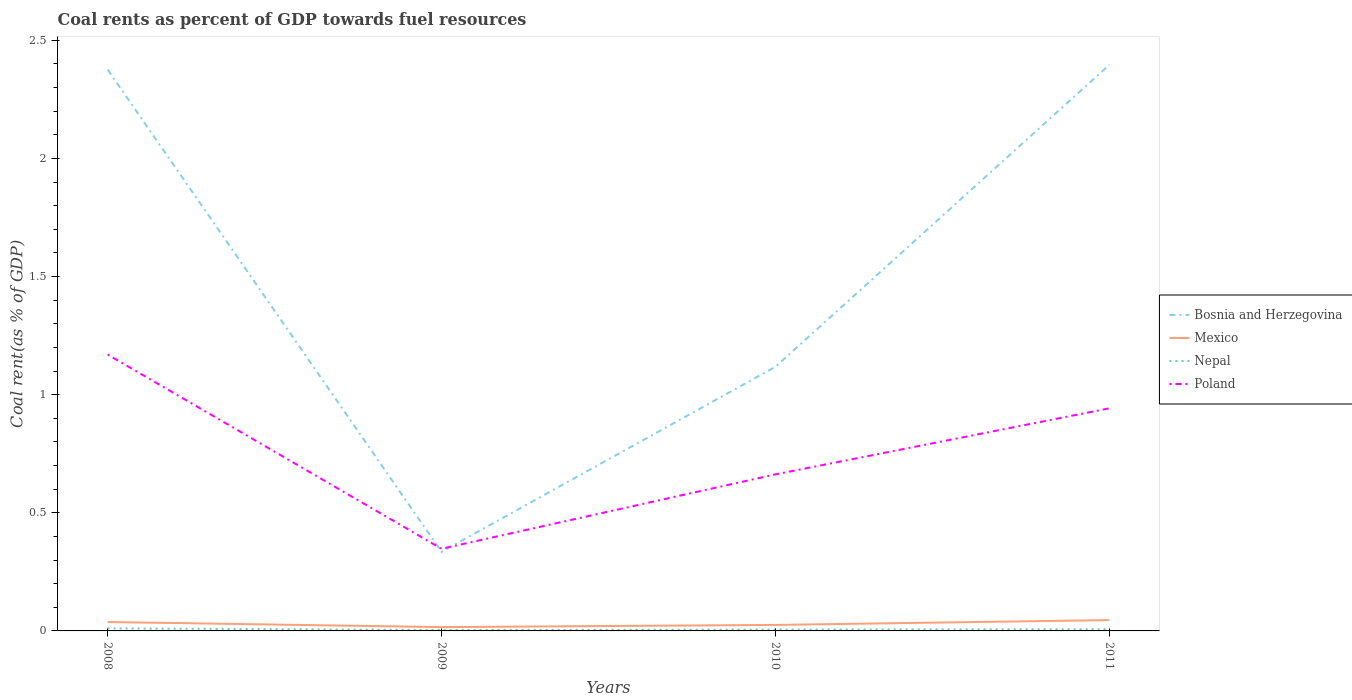How many different coloured lines are there?
Offer a terse response. 4. Is the number of lines equal to the number of legend labels?
Your answer should be very brief. Yes. Across all years, what is the maximum coal rent in Mexico?
Provide a succinct answer. 0.02. What is the total coal rent in Bosnia and Herzegovina in the graph?
Your answer should be compact. 2.04. What is the difference between the highest and the second highest coal rent in Nepal?
Make the answer very short. 0.01. How many years are there in the graph?
Provide a short and direct response. 4. Are the values on the major ticks of Y-axis written in scientific E-notation?
Offer a very short reply. No. Does the graph contain grids?
Keep it short and to the point. No. Where does the legend appear in the graph?
Keep it short and to the point. Center right. How are the legend labels stacked?
Provide a succinct answer. Vertical. What is the title of the graph?
Your answer should be compact. Coal rents as percent of GDP towards fuel resources. What is the label or title of the X-axis?
Your answer should be very brief. Years. What is the label or title of the Y-axis?
Give a very brief answer. Coal rent(as % of GDP). What is the Coal rent(as % of GDP) in Bosnia and Herzegovina in 2008?
Ensure brevity in your answer.  2.38. What is the Coal rent(as % of GDP) in Mexico in 2008?
Make the answer very short. 0.04. What is the Coal rent(as % of GDP) of Nepal in 2008?
Your answer should be compact. 0.01. What is the Coal rent(as % of GDP) of Poland in 2008?
Provide a succinct answer. 1.17. What is the Coal rent(as % of GDP) of Bosnia and Herzegovina in 2009?
Make the answer very short. 0.33. What is the Coal rent(as % of GDP) of Mexico in 2009?
Offer a very short reply. 0.02. What is the Coal rent(as % of GDP) of Nepal in 2009?
Give a very brief answer. 0. What is the Coal rent(as % of GDP) in Poland in 2009?
Your response must be concise. 0.35. What is the Coal rent(as % of GDP) of Bosnia and Herzegovina in 2010?
Offer a terse response. 1.12. What is the Coal rent(as % of GDP) of Mexico in 2010?
Make the answer very short. 0.03. What is the Coal rent(as % of GDP) of Nepal in 2010?
Your answer should be compact. 0.01. What is the Coal rent(as % of GDP) of Poland in 2010?
Make the answer very short. 0.66. What is the Coal rent(as % of GDP) in Bosnia and Herzegovina in 2011?
Keep it short and to the point. 2.4. What is the Coal rent(as % of GDP) of Mexico in 2011?
Offer a very short reply. 0.05. What is the Coal rent(as % of GDP) in Nepal in 2011?
Keep it short and to the point. 0.01. What is the Coal rent(as % of GDP) in Poland in 2011?
Your answer should be very brief. 0.94. Across all years, what is the maximum Coal rent(as % of GDP) in Bosnia and Herzegovina?
Make the answer very short. 2.4. Across all years, what is the maximum Coal rent(as % of GDP) of Mexico?
Your answer should be compact. 0.05. Across all years, what is the maximum Coal rent(as % of GDP) of Nepal?
Ensure brevity in your answer.  0.01. Across all years, what is the maximum Coal rent(as % of GDP) of Poland?
Offer a very short reply. 1.17. Across all years, what is the minimum Coal rent(as % of GDP) in Bosnia and Herzegovina?
Provide a short and direct response. 0.33. Across all years, what is the minimum Coal rent(as % of GDP) of Mexico?
Your answer should be very brief. 0.02. Across all years, what is the minimum Coal rent(as % of GDP) in Nepal?
Ensure brevity in your answer.  0. Across all years, what is the minimum Coal rent(as % of GDP) in Poland?
Offer a very short reply. 0.35. What is the total Coal rent(as % of GDP) of Bosnia and Herzegovina in the graph?
Your answer should be very brief. 6.23. What is the total Coal rent(as % of GDP) in Mexico in the graph?
Your answer should be compact. 0.13. What is the total Coal rent(as % of GDP) of Nepal in the graph?
Offer a very short reply. 0.03. What is the total Coal rent(as % of GDP) of Poland in the graph?
Your answer should be very brief. 3.12. What is the difference between the Coal rent(as % of GDP) of Bosnia and Herzegovina in 2008 and that in 2009?
Offer a terse response. 2.04. What is the difference between the Coal rent(as % of GDP) in Mexico in 2008 and that in 2009?
Provide a succinct answer. 0.02. What is the difference between the Coal rent(as % of GDP) of Nepal in 2008 and that in 2009?
Your response must be concise. 0.01. What is the difference between the Coal rent(as % of GDP) of Poland in 2008 and that in 2009?
Provide a short and direct response. 0.82. What is the difference between the Coal rent(as % of GDP) of Bosnia and Herzegovina in 2008 and that in 2010?
Make the answer very short. 1.26. What is the difference between the Coal rent(as % of GDP) of Mexico in 2008 and that in 2010?
Your answer should be very brief. 0.01. What is the difference between the Coal rent(as % of GDP) of Nepal in 2008 and that in 2010?
Offer a very short reply. 0. What is the difference between the Coal rent(as % of GDP) of Poland in 2008 and that in 2010?
Provide a short and direct response. 0.51. What is the difference between the Coal rent(as % of GDP) in Bosnia and Herzegovina in 2008 and that in 2011?
Keep it short and to the point. -0.02. What is the difference between the Coal rent(as % of GDP) of Mexico in 2008 and that in 2011?
Ensure brevity in your answer.  -0.01. What is the difference between the Coal rent(as % of GDP) of Nepal in 2008 and that in 2011?
Offer a terse response. 0. What is the difference between the Coal rent(as % of GDP) in Poland in 2008 and that in 2011?
Provide a short and direct response. 0.23. What is the difference between the Coal rent(as % of GDP) of Bosnia and Herzegovina in 2009 and that in 2010?
Your answer should be compact. -0.78. What is the difference between the Coal rent(as % of GDP) of Mexico in 2009 and that in 2010?
Offer a terse response. -0.01. What is the difference between the Coal rent(as % of GDP) of Nepal in 2009 and that in 2010?
Your answer should be compact. -0. What is the difference between the Coal rent(as % of GDP) in Poland in 2009 and that in 2010?
Provide a succinct answer. -0.32. What is the difference between the Coal rent(as % of GDP) in Bosnia and Herzegovina in 2009 and that in 2011?
Provide a succinct answer. -2.06. What is the difference between the Coal rent(as % of GDP) in Mexico in 2009 and that in 2011?
Your response must be concise. -0.03. What is the difference between the Coal rent(as % of GDP) of Nepal in 2009 and that in 2011?
Your answer should be very brief. -0. What is the difference between the Coal rent(as % of GDP) of Poland in 2009 and that in 2011?
Make the answer very short. -0.59. What is the difference between the Coal rent(as % of GDP) of Bosnia and Herzegovina in 2010 and that in 2011?
Provide a short and direct response. -1.28. What is the difference between the Coal rent(as % of GDP) in Mexico in 2010 and that in 2011?
Provide a succinct answer. -0.02. What is the difference between the Coal rent(as % of GDP) of Nepal in 2010 and that in 2011?
Your response must be concise. -0. What is the difference between the Coal rent(as % of GDP) in Poland in 2010 and that in 2011?
Provide a short and direct response. -0.28. What is the difference between the Coal rent(as % of GDP) of Bosnia and Herzegovina in 2008 and the Coal rent(as % of GDP) of Mexico in 2009?
Give a very brief answer. 2.36. What is the difference between the Coal rent(as % of GDP) in Bosnia and Herzegovina in 2008 and the Coal rent(as % of GDP) in Nepal in 2009?
Offer a terse response. 2.37. What is the difference between the Coal rent(as % of GDP) of Bosnia and Herzegovina in 2008 and the Coal rent(as % of GDP) of Poland in 2009?
Your answer should be very brief. 2.03. What is the difference between the Coal rent(as % of GDP) in Mexico in 2008 and the Coal rent(as % of GDP) in Nepal in 2009?
Your response must be concise. 0.03. What is the difference between the Coal rent(as % of GDP) of Mexico in 2008 and the Coal rent(as % of GDP) of Poland in 2009?
Your answer should be very brief. -0.31. What is the difference between the Coal rent(as % of GDP) in Nepal in 2008 and the Coal rent(as % of GDP) in Poland in 2009?
Keep it short and to the point. -0.34. What is the difference between the Coal rent(as % of GDP) in Bosnia and Herzegovina in 2008 and the Coal rent(as % of GDP) in Mexico in 2010?
Make the answer very short. 2.35. What is the difference between the Coal rent(as % of GDP) in Bosnia and Herzegovina in 2008 and the Coal rent(as % of GDP) in Nepal in 2010?
Provide a short and direct response. 2.37. What is the difference between the Coal rent(as % of GDP) of Bosnia and Herzegovina in 2008 and the Coal rent(as % of GDP) of Poland in 2010?
Offer a terse response. 1.71. What is the difference between the Coal rent(as % of GDP) in Mexico in 2008 and the Coal rent(as % of GDP) in Nepal in 2010?
Your answer should be very brief. 0.03. What is the difference between the Coal rent(as % of GDP) in Mexico in 2008 and the Coal rent(as % of GDP) in Poland in 2010?
Offer a very short reply. -0.62. What is the difference between the Coal rent(as % of GDP) in Nepal in 2008 and the Coal rent(as % of GDP) in Poland in 2010?
Make the answer very short. -0.65. What is the difference between the Coal rent(as % of GDP) in Bosnia and Herzegovina in 2008 and the Coal rent(as % of GDP) in Mexico in 2011?
Your answer should be very brief. 2.33. What is the difference between the Coal rent(as % of GDP) of Bosnia and Herzegovina in 2008 and the Coal rent(as % of GDP) of Nepal in 2011?
Ensure brevity in your answer.  2.37. What is the difference between the Coal rent(as % of GDP) of Bosnia and Herzegovina in 2008 and the Coal rent(as % of GDP) of Poland in 2011?
Offer a very short reply. 1.43. What is the difference between the Coal rent(as % of GDP) of Mexico in 2008 and the Coal rent(as % of GDP) of Nepal in 2011?
Provide a short and direct response. 0.03. What is the difference between the Coal rent(as % of GDP) in Mexico in 2008 and the Coal rent(as % of GDP) in Poland in 2011?
Give a very brief answer. -0.9. What is the difference between the Coal rent(as % of GDP) in Nepal in 2008 and the Coal rent(as % of GDP) in Poland in 2011?
Provide a succinct answer. -0.93. What is the difference between the Coal rent(as % of GDP) in Bosnia and Herzegovina in 2009 and the Coal rent(as % of GDP) in Mexico in 2010?
Ensure brevity in your answer.  0.31. What is the difference between the Coal rent(as % of GDP) in Bosnia and Herzegovina in 2009 and the Coal rent(as % of GDP) in Nepal in 2010?
Provide a short and direct response. 0.33. What is the difference between the Coal rent(as % of GDP) of Bosnia and Herzegovina in 2009 and the Coal rent(as % of GDP) of Poland in 2010?
Offer a very short reply. -0.33. What is the difference between the Coal rent(as % of GDP) of Mexico in 2009 and the Coal rent(as % of GDP) of Nepal in 2010?
Your answer should be compact. 0.01. What is the difference between the Coal rent(as % of GDP) in Mexico in 2009 and the Coal rent(as % of GDP) in Poland in 2010?
Make the answer very short. -0.65. What is the difference between the Coal rent(as % of GDP) in Nepal in 2009 and the Coal rent(as % of GDP) in Poland in 2010?
Keep it short and to the point. -0.66. What is the difference between the Coal rent(as % of GDP) of Bosnia and Herzegovina in 2009 and the Coal rent(as % of GDP) of Mexico in 2011?
Your answer should be very brief. 0.29. What is the difference between the Coal rent(as % of GDP) in Bosnia and Herzegovina in 2009 and the Coal rent(as % of GDP) in Nepal in 2011?
Ensure brevity in your answer.  0.33. What is the difference between the Coal rent(as % of GDP) in Bosnia and Herzegovina in 2009 and the Coal rent(as % of GDP) in Poland in 2011?
Make the answer very short. -0.61. What is the difference between the Coal rent(as % of GDP) of Mexico in 2009 and the Coal rent(as % of GDP) of Nepal in 2011?
Ensure brevity in your answer.  0.01. What is the difference between the Coal rent(as % of GDP) of Mexico in 2009 and the Coal rent(as % of GDP) of Poland in 2011?
Offer a very short reply. -0.93. What is the difference between the Coal rent(as % of GDP) of Nepal in 2009 and the Coal rent(as % of GDP) of Poland in 2011?
Give a very brief answer. -0.94. What is the difference between the Coal rent(as % of GDP) in Bosnia and Herzegovina in 2010 and the Coal rent(as % of GDP) in Mexico in 2011?
Your answer should be very brief. 1.07. What is the difference between the Coal rent(as % of GDP) in Bosnia and Herzegovina in 2010 and the Coal rent(as % of GDP) in Nepal in 2011?
Provide a short and direct response. 1.11. What is the difference between the Coal rent(as % of GDP) in Bosnia and Herzegovina in 2010 and the Coal rent(as % of GDP) in Poland in 2011?
Your answer should be very brief. 0.18. What is the difference between the Coal rent(as % of GDP) of Mexico in 2010 and the Coal rent(as % of GDP) of Nepal in 2011?
Provide a short and direct response. 0.02. What is the difference between the Coal rent(as % of GDP) of Mexico in 2010 and the Coal rent(as % of GDP) of Poland in 2011?
Give a very brief answer. -0.92. What is the difference between the Coal rent(as % of GDP) of Nepal in 2010 and the Coal rent(as % of GDP) of Poland in 2011?
Provide a succinct answer. -0.94. What is the average Coal rent(as % of GDP) of Bosnia and Herzegovina per year?
Your answer should be very brief. 1.56. What is the average Coal rent(as % of GDP) in Mexico per year?
Offer a very short reply. 0.03. What is the average Coal rent(as % of GDP) of Nepal per year?
Keep it short and to the point. 0.01. What is the average Coal rent(as % of GDP) of Poland per year?
Your answer should be very brief. 0.78. In the year 2008, what is the difference between the Coal rent(as % of GDP) of Bosnia and Herzegovina and Coal rent(as % of GDP) of Mexico?
Your answer should be very brief. 2.34. In the year 2008, what is the difference between the Coal rent(as % of GDP) of Bosnia and Herzegovina and Coal rent(as % of GDP) of Nepal?
Give a very brief answer. 2.37. In the year 2008, what is the difference between the Coal rent(as % of GDP) in Bosnia and Herzegovina and Coal rent(as % of GDP) in Poland?
Provide a short and direct response. 1.21. In the year 2008, what is the difference between the Coal rent(as % of GDP) in Mexico and Coal rent(as % of GDP) in Nepal?
Your answer should be compact. 0.03. In the year 2008, what is the difference between the Coal rent(as % of GDP) in Mexico and Coal rent(as % of GDP) in Poland?
Offer a very short reply. -1.13. In the year 2008, what is the difference between the Coal rent(as % of GDP) of Nepal and Coal rent(as % of GDP) of Poland?
Provide a succinct answer. -1.16. In the year 2009, what is the difference between the Coal rent(as % of GDP) of Bosnia and Herzegovina and Coal rent(as % of GDP) of Mexico?
Your answer should be very brief. 0.32. In the year 2009, what is the difference between the Coal rent(as % of GDP) of Bosnia and Herzegovina and Coal rent(as % of GDP) of Nepal?
Ensure brevity in your answer.  0.33. In the year 2009, what is the difference between the Coal rent(as % of GDP) of Bosnia and Herzegovina and Coal rent(as % of GDP) of Poland?
Offer a terse response. -0.01. In the year 2009, what is the difference between the Coal rent(as % of GDP) of Mexico and Coal rent(as % of GDP) of Nepal?
Ensure brevity in your answer.  0.01. In the year 2009, what is the difference between the Coal rent(as % of GDP) in Mexico and Coal rent(as % of GDP) in Poland?
Give a very brief answer. -0.33. In the year 2009, what is the difference between the Coal rent(as % of GDP) in Nepal and Coal rent(as % of GDP) in Poland?
Offer a very short reply. -0.34. In the year 2010, what is the difference between the Coal rent(as % of GDP) in Bosnia and Herzegovina and Coal rent(as % of GDP) in Mexico?
Keep it short and to the point. 1.09. In the year 2010, what is the difference between the Coal rent(as % of GDP) in Bosnia and Herzegovina and Coal rent(as % of GDP) in Nepal?
Your answer should be very brief. 1.11. In the year 2010, what is the difference between the Coal rent(as % of GDP) of Bosnia and Herzegovina and Coal rent(as % of GDP) of Poland?
Your answer should be compact. 0.46. In the year 2010, what is the difference between the Coal rent(as % of GDP) in Mexico and Coal rent(as % of GDP) in Nepal?
Your answer should be very brief. 0.02. In the year 2010, what is the difference between the Coal rent(as % of GDP) of Mexico and Coal rent(as % of GDP) of Poland?
Offer a terse response. -0.64. In the year 2010, what is the difference between the Coal rent(as % of GDP) in Nepal and Coal rent(as % of GDP) in Poland?
Offer a terse response. -0.66. In the year 2011, what is the difference between the Coal rent(as % of GDP) in Bosnia and Herzegovina and Coal rent(as % of GDP) in Mexico?
Offer a very short reply. 2.35. In the year 2011, what is the difference between the Coal rent(as % of GDP) in Bosnia and Herzegovina and Coal rent(as % of GDP) in Nepal?
Your response must be concise. 2.39. In the year 2011, what is the difference between the Coal rent(as % of GDP) in Bosnia and Herzegovina and Coal rent(as % of GDP) in Poland?
Offer a terse response. 1.45. In the year 2011, what is the difference between the Coal rent(as % of GDP) of Mexico and Coal rent(as % of GDP) of Nepal?
Offer a very short reply. 0.04. In the year 2011, what is the difference between the Coal rent(as % of GDP) in Mexico and Coal rent(as % of GDP) in Poland?
Ensure brevity in your answer.  -0.9. In the year 2011, what is the difference between the Coal rent(as % of GDP) of Nepal and Coal rent(as % of GDP) of Poland?
Your response must be concise. -0.94. What is the ratio of the Coal rent(as % of GDP) in Bosnia and Herzegovina in 2008 to that in 2009?
Provide a short and direct response. 7.1. What is the ratio of the Coal rent(as % of GDP) of Mexico in 2008 to that in 2009?
Offer a very short reply. 2.33. What is the ratio of the Coal rent(as % of GDP) in Nepal in 2008 to that in 2009?
Provide a succinct answer. 2.57. What is the ratio of the Coal rent(as % of GDP) of Poland in 2008 to that in 2009?
Your answer should be very brief. 3.36. What is the ratio of the Coal rent(as % of GDP) of Bosnia and Herzegovina in 2008 to that in 2010?
Provide a succinct answer. 2.13. What is the ratio of the Coal rent(as % of GDP) of Mexico in 2008 to that in 2010?
Your response must be concise. 1.48. What is the ratio of the Coal rent(as % of GDP) in Nepal in 2008 to that in 2010?
Ensure brevity in your answer.  1.85. What is the ratio of the Coal rent(as % of GDP) of Poland in 2008 to that in 2010?
Give a very brief answer. 1.77. What is the ratio of the Coal rent(as % of GDP) of Bosnia and Herzegovina in 2008 to that in 2011?
Ensure brevity in your answer.  0.99. What is the ratio of the Coal rent(as % of GDP) of Mexico in 2008 to that in 2011?
Ensure brevity in your answer.  0.82. What is the ratio of the Coal rent(as % of GDP) in Nepal in 2008 to that in 2011?
Provide a succinct answer. 1.47. What is the ratio of the Coal rent(as % of GDP) in Poland in 2008 to that in 2011?
Your answer should be compact. 1.24. What is the ratio of the Coal rent(as % of GDP) of Bosnia and Herzegovina in 2009 to that in 2010?
Offer a terse response. 0.3. What is the ratio of the Coal rent(as % of GDP) of Mexico in 2009 to that in 2010?
Give a very brief answer. 0.64. What is the ratio of the Coal rent(as % of GDP) in Nepal in 2009 to that in 2010?
Your answer should be very brief. 0.72. What is the ratio of the Coal rent(as % of GDP) in Poland in 2009 to that in 2010?
Your answer should be very brief. 0.52. What is the ratio of the Coal rent(as % of GDP) of Bosnia and Herzegovina in 2009 to that in 2011?
Your answer should be compact. 0.14. What is the ratio of the Coal rent(as % of GDP) of Mexico in 2009 to that in 2011?
Your response must be concise. 0.35. What is the ratio of the Coal rent(as % of GDP) in Nepal in 2009 to that in 2011?
Provide a short and direct response. 0.57. What is the ratio of the Coal rent(as % of GDP) in Poland in 2009 to that in 2011?
Ensure brevity in your answer.  0.37. What is the ratio of the Coal rent(as % of GDP) in Bosnia and Herzegovina in 2010 to that in 2011?
Make the answer very short. 0.47. What is the ratio of the Coal rent(as % of GDP) in Mexico in 2010 to that in 2011?
Provide a succinct answer. 0.55. What is the ratio of the Coal rent(as % of GDP) in Nepal in 2010 to that in 2011?
Your answer should be very brief. 0.79. What is the ratio of the Coal rent(as % of GDP) in Poland in 2010 to that in 2011?
Offer a terse response. 0.7. What is the difference between the highest and the second highest Coal rent(as % of GDP) of Bosnia and Herzegovina?
Provide a succinct answer. 0.02. What is the difference between the highest and the second highest Coal rent(as % of GDP) in Mexico?
Your answer should be compact. 0.01. What is the difference between the highest and the second highest Coal rent(as % of GDP) in Nepal?
Provide a short and direct response. 0. What is the difference between the highest and the second highest Coal rent(as % of GDP) in Poland?
Keep it short and to the point. 0.23. What is the difference between the highest and the lowest Coal rent(as % of GDP) in Bosnia and Herzegovina?
Your answer should be very brief. 2.06. What is the difference between the highest and the lowest Coal rent(as % of GDP) of Mexico?
Make the answer very short. 0.03. What is the difference between the highest and the lowest Coal rent(as % of GDP) in Nepal?
Provide a succinct answer. 0.01. What is the difference between the highest and the lowest Coal rent(as % of GDP) in Poland?
Offer a very short reply. 0.82. 